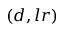Convert formula to latex. <formula><loc_0><loc_0><loc_500><loc_500>( d , l r )</formula> 